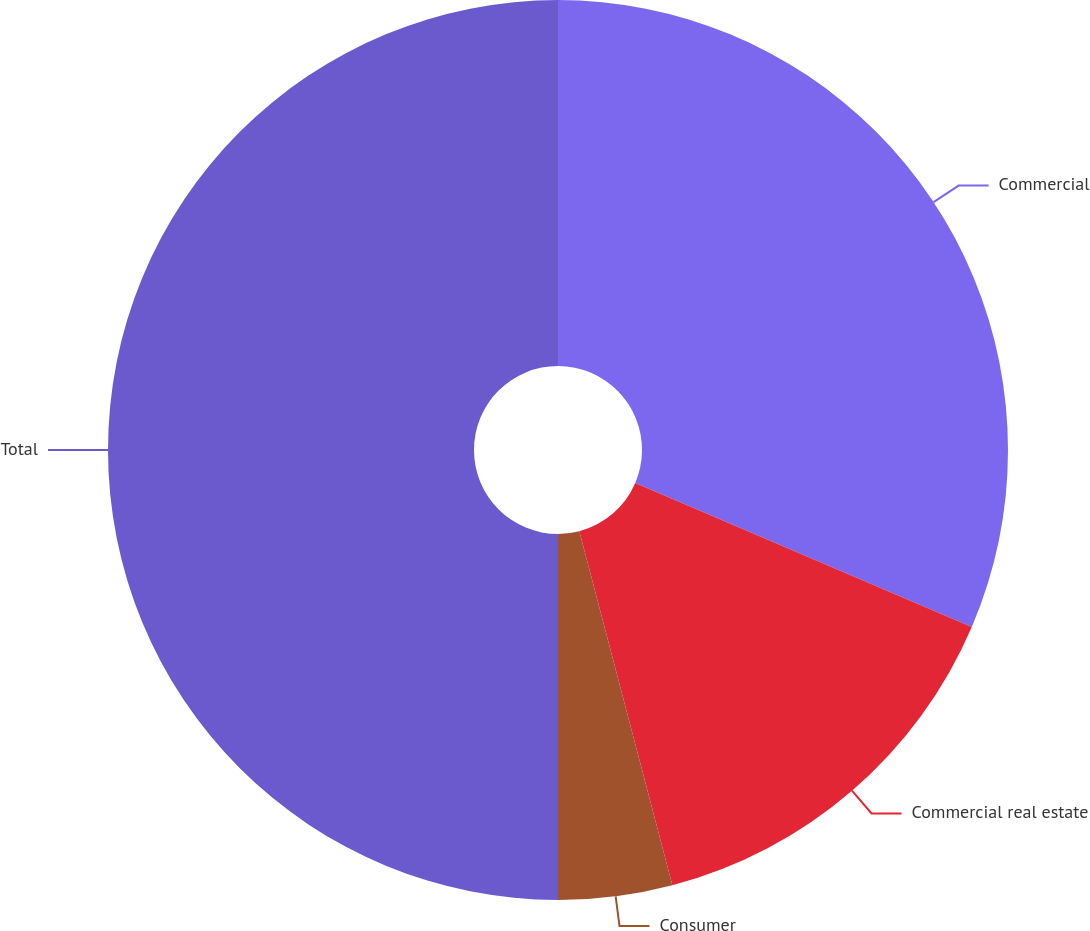Convert chart to OTSL. <chart><loc_0><loc_0><loc_500><loc_500><pie_chart><fcel>Commercial<fcel>Commercial real estate<fcel>Consumer<fcel>Total<nl><fcel>31.43%<fcel>14.48%<fcel>4.09%<fcel>50.0%<nl></chart> 